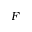<formula> <loc_0><loc_0><loc_500><loc_500>F</formula> 